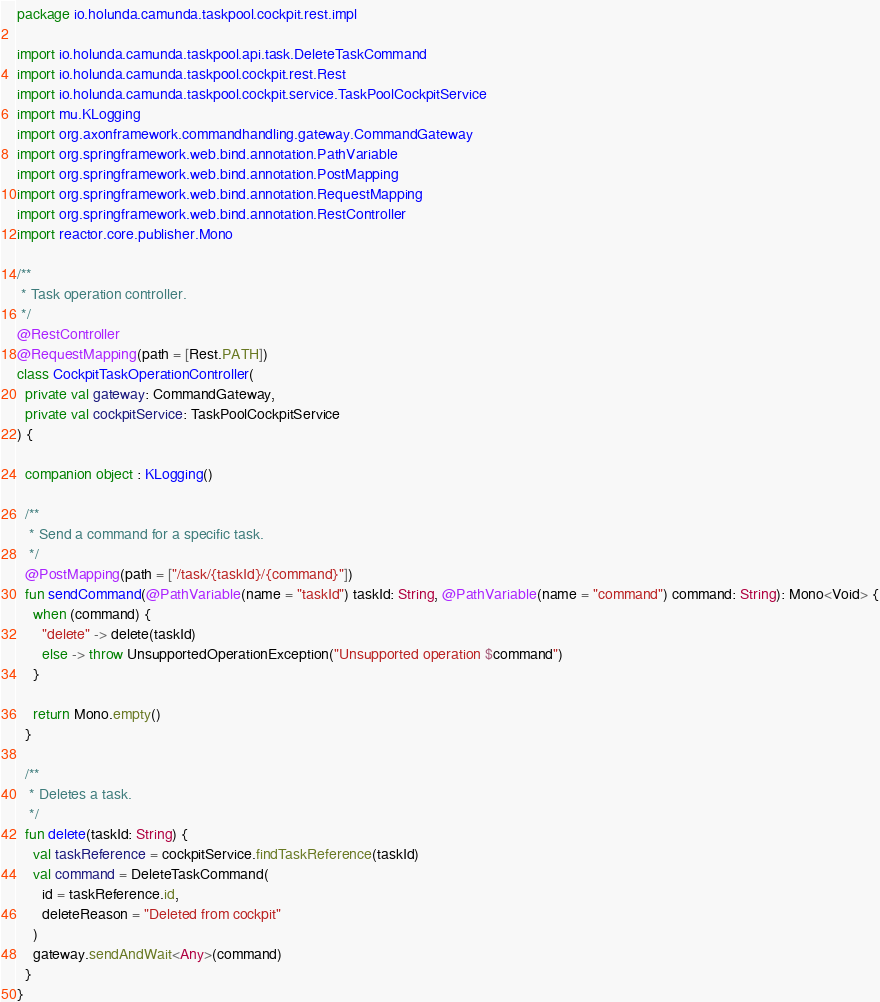<code> <loc_0><loc_0><loc_500><loc_500><_Kotlin_>package io.holunda.camunda.taskpool.cockpit.rest.impl

import io.holunda.camunda.taskpool.api.task.DeleteTaskCommand
import io.holunda.camunda.taskpool.cockpit.rest.Rest
import io.holunda.camunda.taskpool.cockpit.service.TaskPoolCockpitService
import mu.KLogging
import org.axonframework.commandhandling.gateway.CommandGateway
import org.springframework.web.bind.annotation.PathVariable
import org.springframework.web.bind.annotation.PostMapping
import org.springframework.web.bind.annotation.RequestMapping
import org.springframework.web.bind.annotation.RestController
import reactor.core.publisher.Mono

/**
 * Task operation controller.
 */
@RestController
@RequestMapping(path = [Rest.PATH])
class CockpitTaskOperationController(
  private val gateway: CommandGateway,
  private val cockpitService: TaskPoolCockpitService
) {

  companion object : KLogging()

  /**
   * Send a command for a specific task.
   */
  @PostMapping(path = ["/task/{taskId}/{command}"])
  fun sendCommand(@PathVariable(name = "taskId") taskId: String, @PathVariable(name = "command") command: String): Mono<Void> {
    when (command) {
      "delete" -> delete(taskId)
      else -> throw UnsupportedOperationException("Unsupported operation $command")
    }

    return Mono.empty()
  }

  /**
   * Deletes a task.
   */
  fun delete(taskId: String) {
    val taskReference = cockpitService.findTaskReference(taskId)
    val command = DeleteTaskCommand(
      id = taskReference.id,
      deleteReason = "Deleted from cockpit"
    )
    gateway.sendAndWait<Any>(command)
  }
}
</code> 